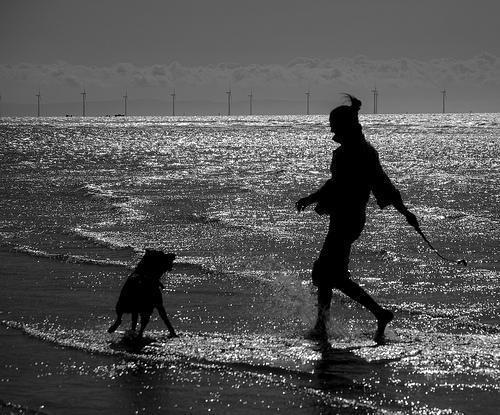How many dogs in the water?
Give a very brief answer. 1. 